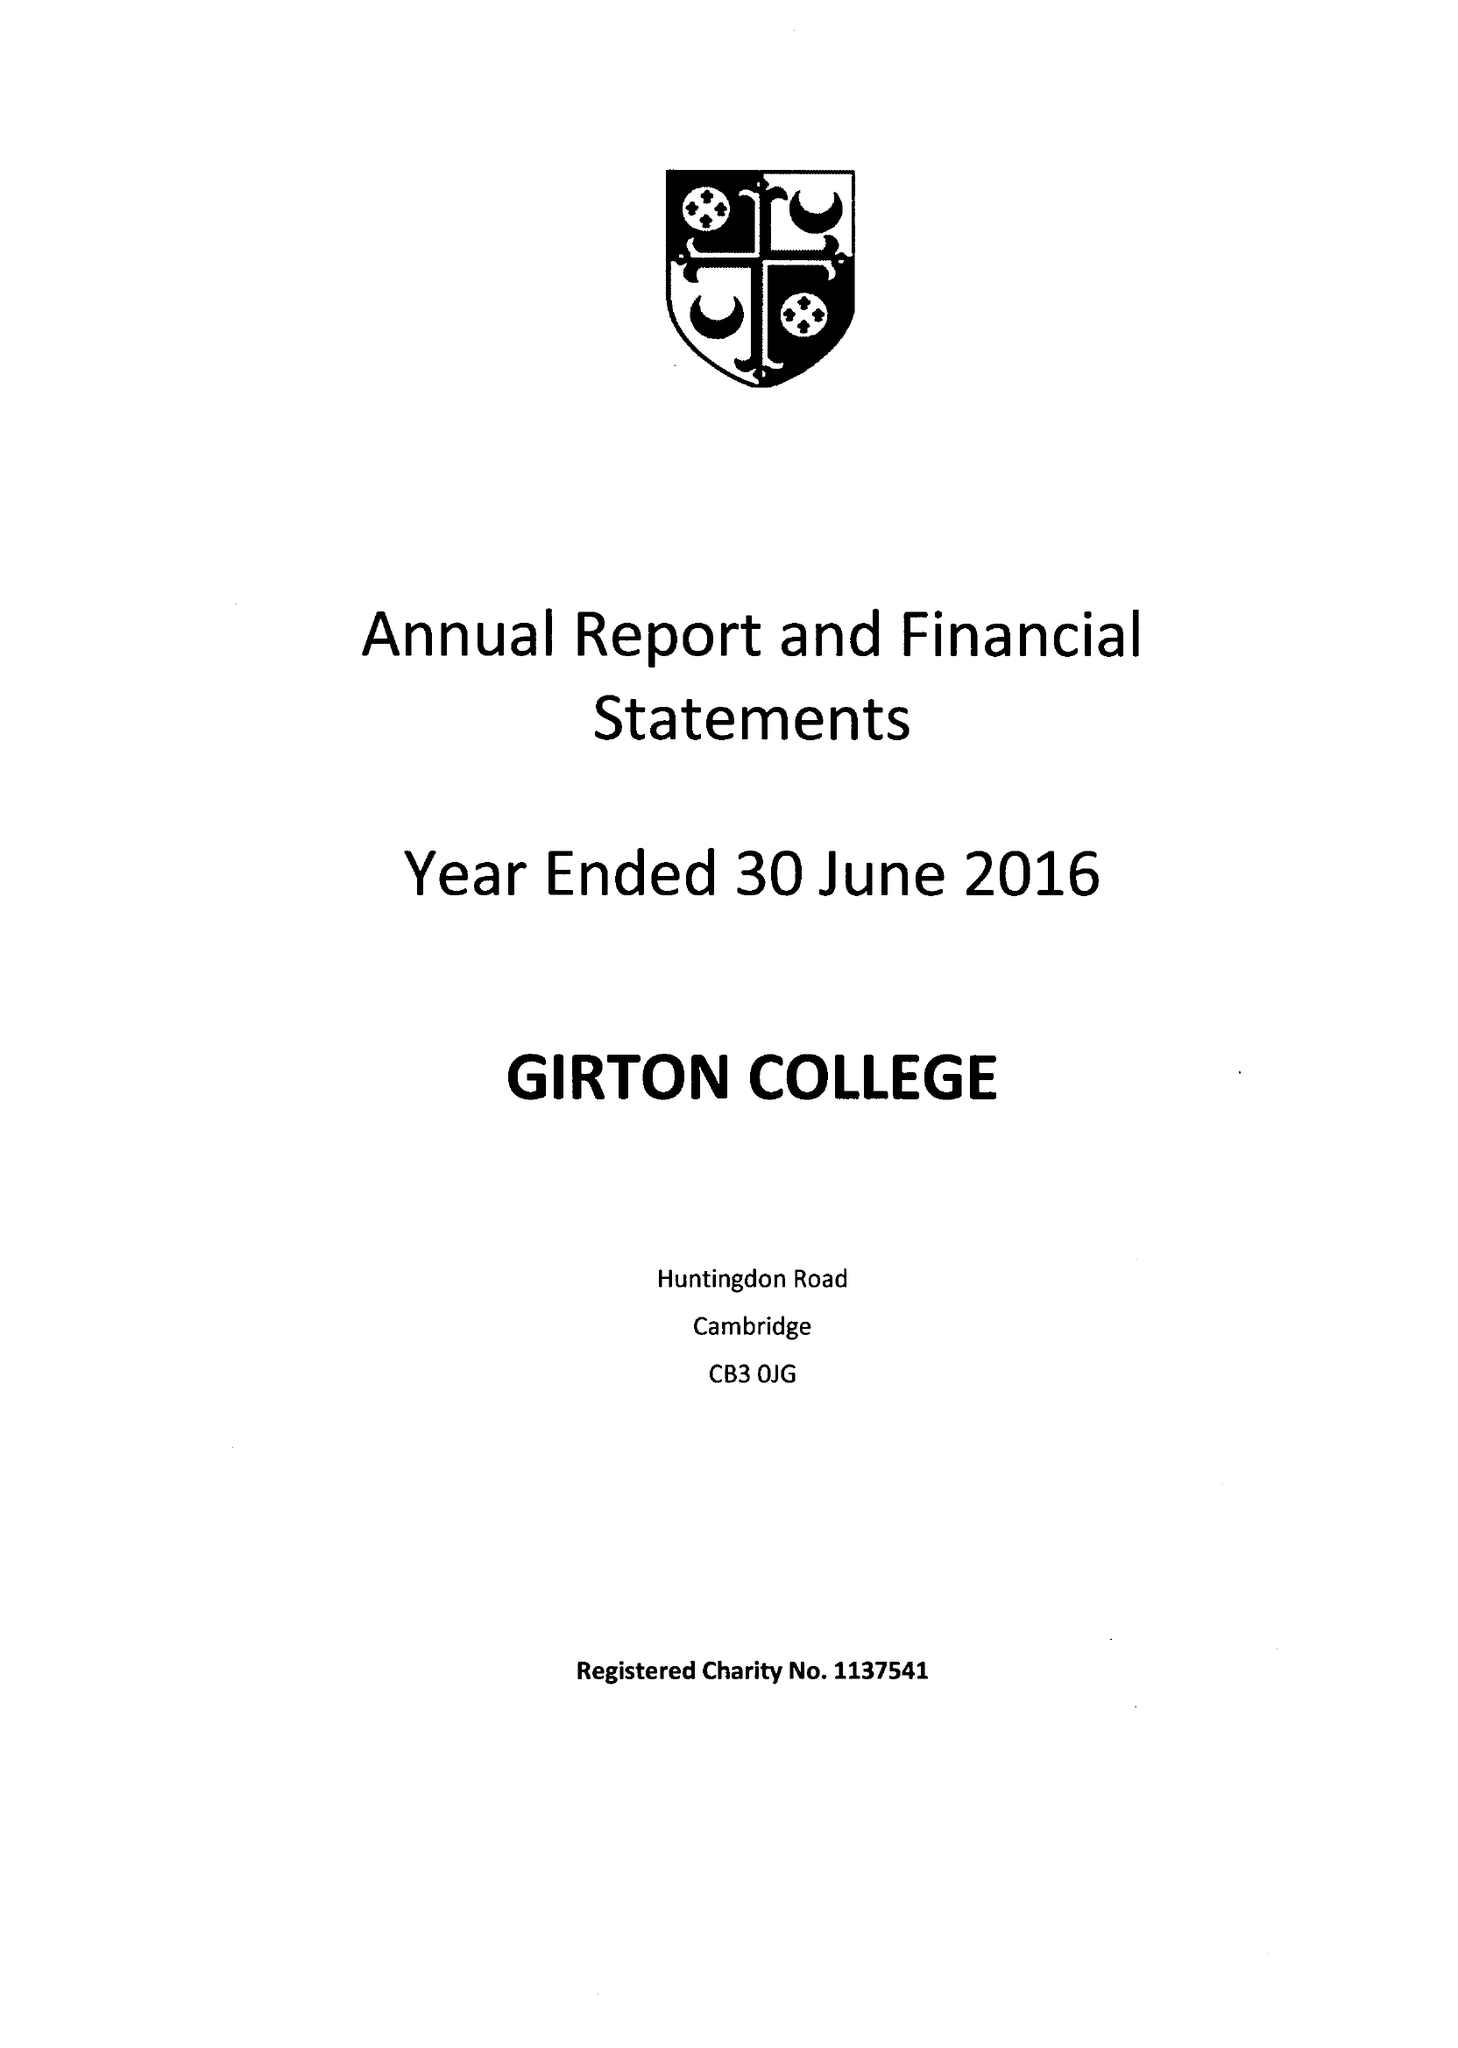What is the value for the spending_annually_in_british_pounds?
Answer the question using a single word or phrase. 12226000.00 